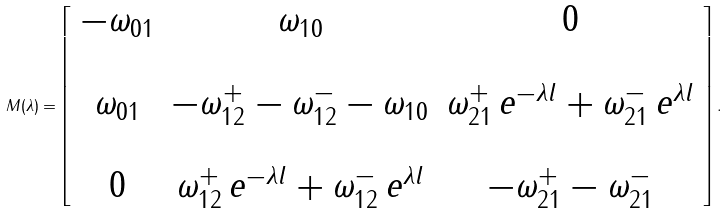<formula> <loc_0><loc_0><loc_500><loc_500>M ( \lambda ) = \left [ \begin{array} { c c c } - \omega _ { 0 1 } & \omega _ { 1 0 } & 0 \\ & & \\ \omega _ { 0 1 } & - \omega _ { 1 2 } ^ { + } - \omega _ { 1 2 } ^ { - } - \omega _ { 1 0 } & \omega _ { 2 1 } ^ { + } \, e ^ { - \lambda l } + \omega _ { 2 1 } ^ { - } \, e ^ { \lambda l } \\ & & \\ 0 & \omega _ { 1 2 } ^ { + } \, e ^ { - \lambda l } + \omega _ { 1 2 } ^ { - } \, e ^ { \lambda l } & - \omega _ { 2 1 } ^ { + } - \omega _ { 2 1 } ^ { - } \end{array} \right ] .</formula> 